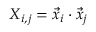Convert formula to latex. <formula><loc_0><loc_0><loc_500><loc_500>X _ { i , j } = \ V e c { x } _ { i } \cdot \ V e c { x } _ { j }</formula> 